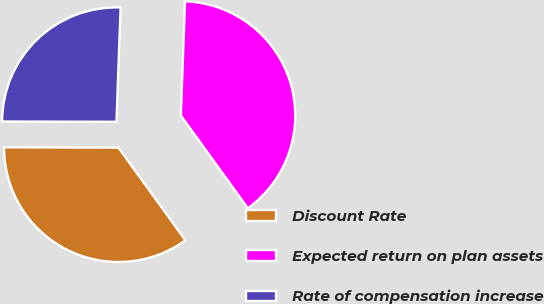<chart> <loc_0><loc_0><loc_500><loc_500><pie_chart><fcel>Discount Rate<fcel>Expected return on plan assets<fcel>Rate of compensation increase<nl><fcel>35.0%<fcel>39.47%<fcel>25.54%<nl></chart> 